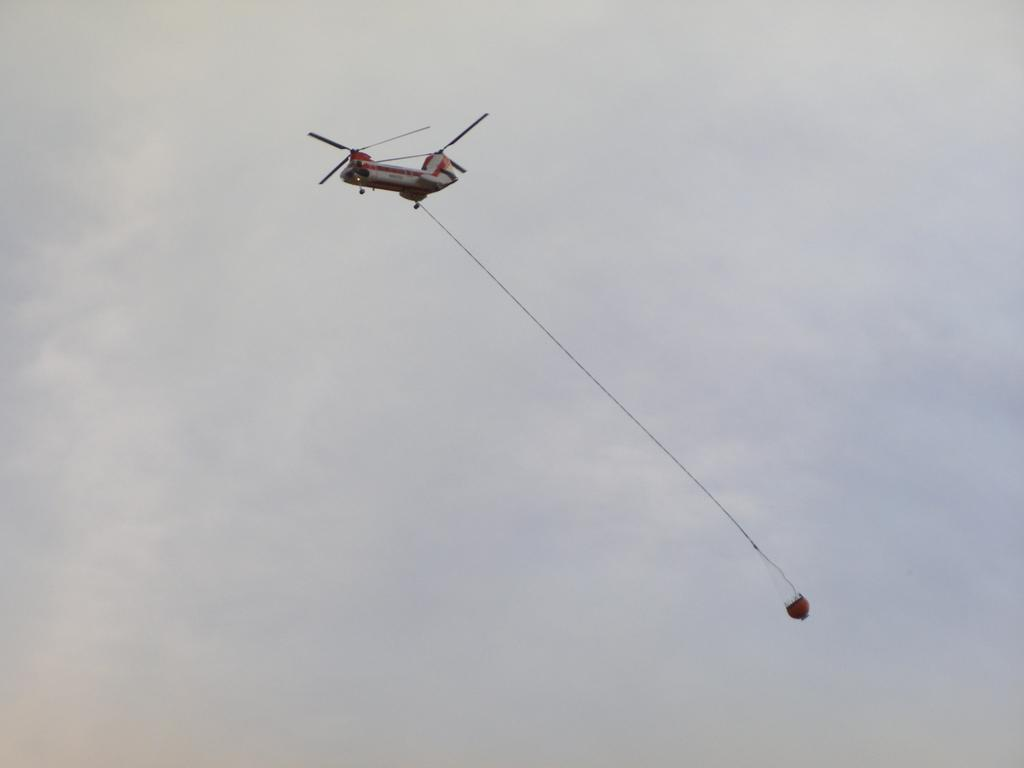What is the main subject of the image? The main subject of the image is a flying jet. Is there anything connected to the jet in the image? Yes, a rope is attached to the jet. What is at the end of the rope? There is an object at the end of the rope. How would you describe the weather in the image? The sky is cloudy in the image. What type of rail is visible in the image? There is no rail present in the image; it features a flying jet with a rope and an object attached to it. Is there a collar visible on the jet in the image? Jets do not have collars, and there is no collar present in the image. 